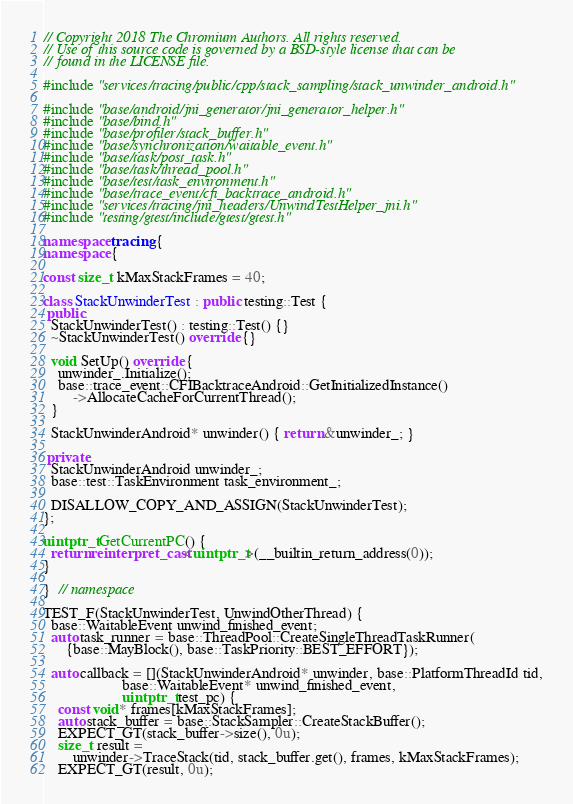Convert code to text. <code><loc_0><loc_0><loc_500><loc_500><_C++_>// Copyright 2018 The Chromium Authors. All rights reserved.
// Use of this source code is governed by a BSD-style license that can be
// found in the LICENSE file.

#include "services/tracing/public/cpp/stack_sampling/stack_unwinder_android.h"

#include "base/android/jni_generator/jni_generator_helper.h"
#include "base/bind.h"
#include "base/profiler/stack_buffer.h"
#include "base/synchronization/waitable_event.h"
#include "base/task/post_task.h"
#include "base/task/thread_pool.h"
#include "base/test/task_environment.h"
#include "base/trace_event/cfi_backtrace_android.h"
#include "services/tracing/jni_headers/UnwindTestHelper_jni.h"
#include "testing/gtest/include/gtest/gtest.h"

namespace tracing {
namespace {

const size_t kMaxStackFrames = 40;

class StackUnwinderTest : public testing::Test {
 public:
  StackUnwinderTest() : testing::Test() {}
  ~StackUnwinderTest() override {}

  void SetUp() override {
    unwinder_.Initialize();
    base::trace_event::CFIBacktraceAndroid::GetInitializedInstance()
        ->AllocateCacheForCurrentThread();
  }

  StackUnwinderAndroid* unwinder() { return &unwinder_; }

 private:
  StackUnwinderAndroid unwinder_;
  base::test::TaskEnvironment task_environment_;

  DISALLOW_COPY_AND_ASSIGN(StackUnwinderTest);
};

uintptr_t GetCurrentPC() {
  return reinterpret_cast<uintptr_t>(__builtin_return_address(0));
}

}  // namespace

TEST_F(StackUnwinderTest, UnwindOtherThread) {
  base::WaitableEvent unwind_finished_event;
  auto task_runner = base::ThreadPool::CreateSingleThreadTaskRunner(
      {base::MayBlock(), base::TaskPriority::BEST_EFFORT});

  auto callback = [](StackUnwinderAndroid* unwinder, base::PlatformThreadId tid,
                     base::WaitableEvent* unwind_finished_event,
                     uintptr_t test_pc) {
    const void* frames[kMaxStackFrames];
    auto stack_buffer = base::StackSampler::CreateStackBuffer();
    EXPECT_GT(stack_buffer->size(), 0u);
    size_t result =
        unwinder->TraceStack(tid, stack_buffer.get(), frames, kMaxStackFrames);
    EXPECT_GT(result, 0u);</code> 